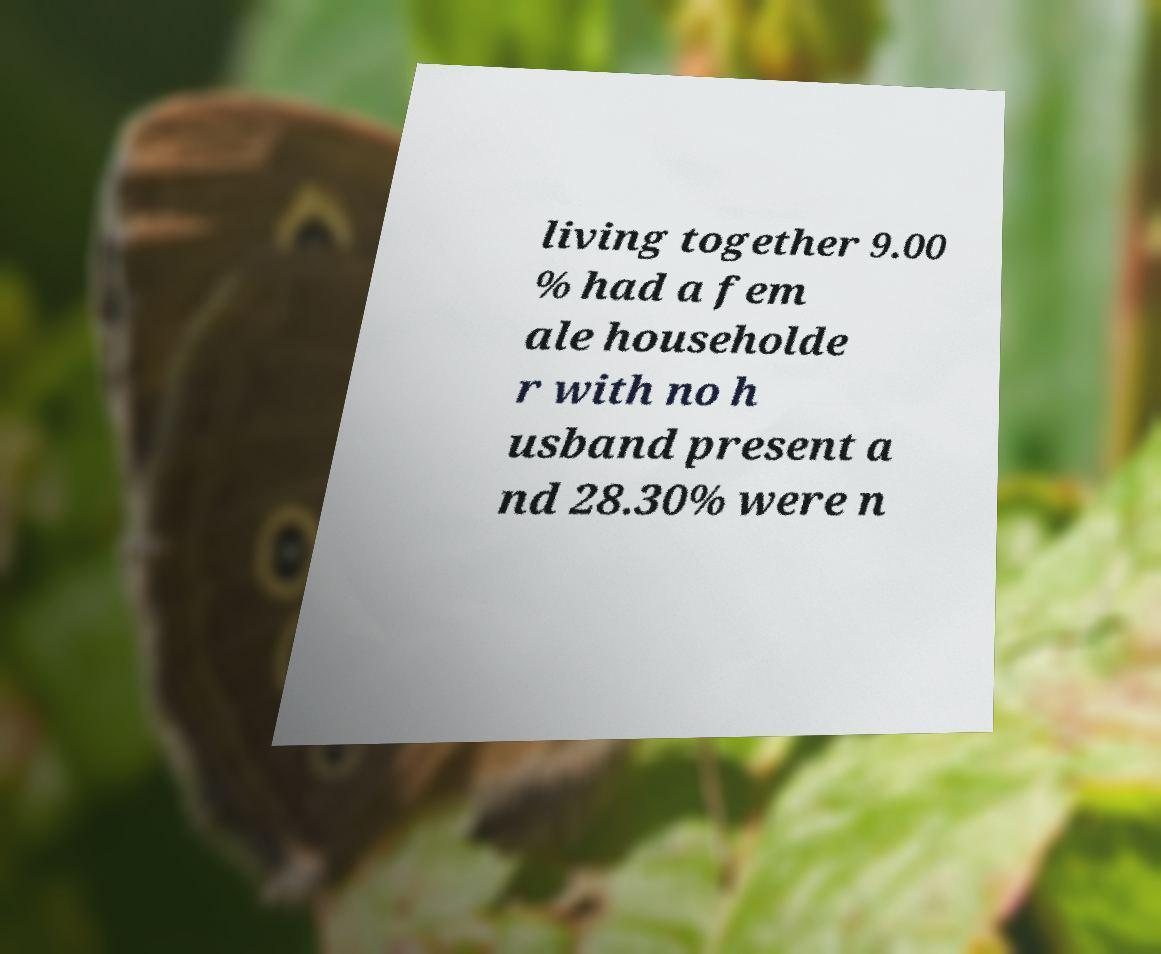Can you read and provide the text displayed in the image?This photo seems to have some interesting text. Can you extract and type it out for me? living together 9.00 % had a fem ale householde r with no h usband present a nd 28.30% were n 